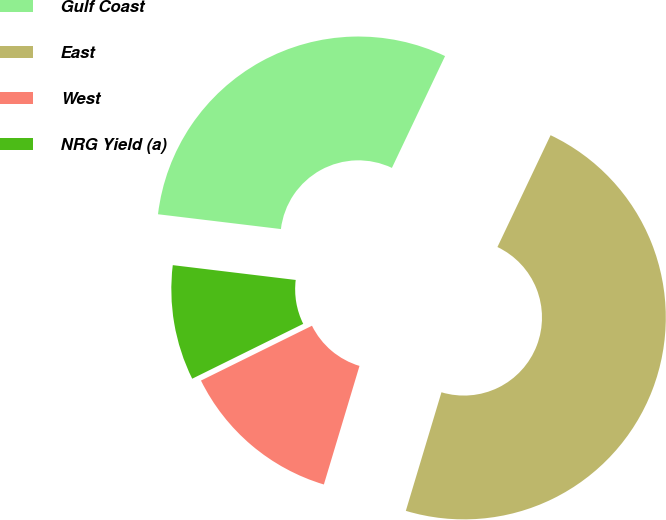Convert chart. <chart><loc_0><loc_0><loc_500><loc_500><pie_chart><fcel>Gulf Coast<fcel>East<fcel>West<fcel>NRG Yield (a)<nl><fcel>30.15%<fcel>47.58%<fcel>13.05%<fcel>9.21%<nl></chart> 